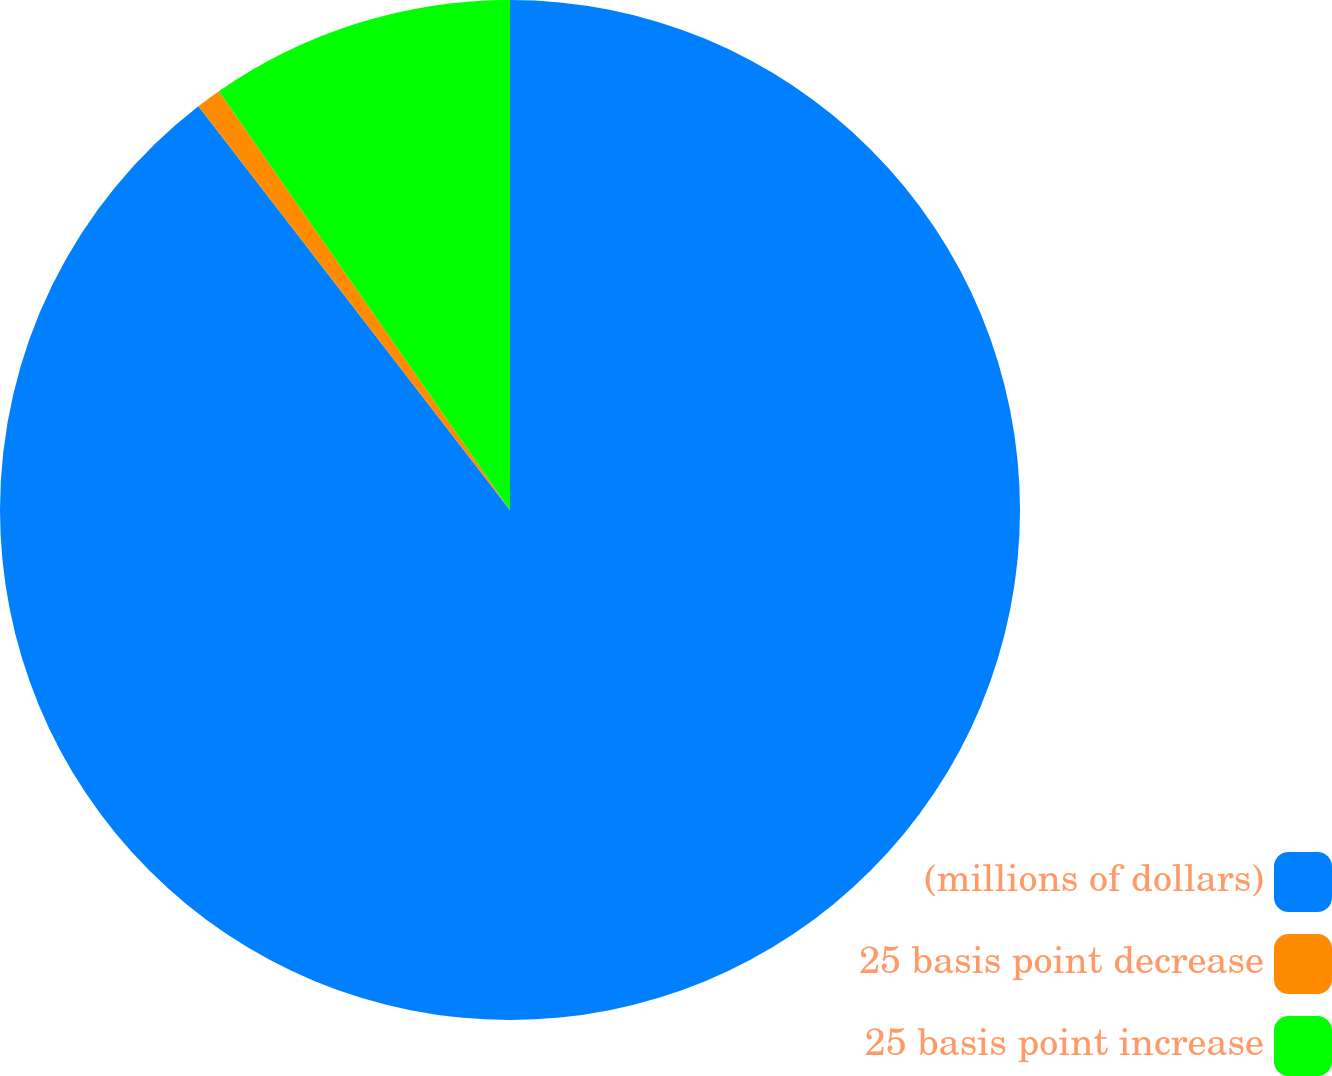Convert chart to OTSL. <chart><loc_0><loc_0><loc_500><loc_500><pie_chart><fcel>(millions of dollars)<fcel>25 basis point decrease<fcel>25 basis point increase<nl><fcel>89.54%<fcel>0.79%<fcel>9.67%<nl></chart> 